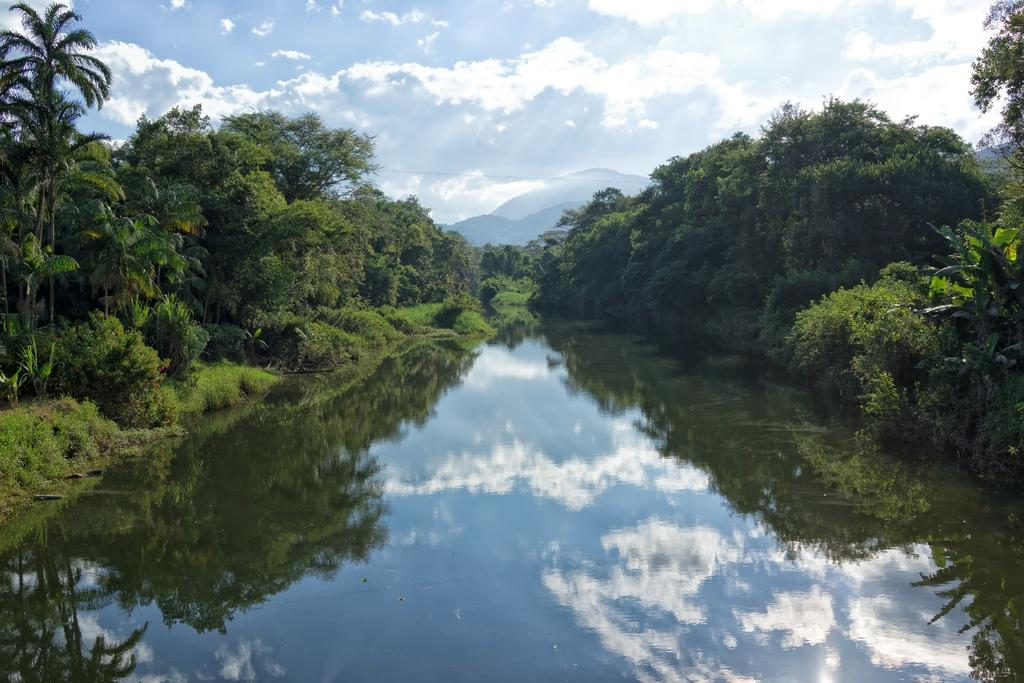What type of vegetation can be seen in the image? There are trees in the image. What is the color of the trees? The trees are green in color. What else is visible in the image besides the trees? There is water visible in the image. What can be seen in the background of the image? The sky is visible in the background of the image. What colors are present in the sky? The sky has both white and blue colors. Can you see a rake being used to gather rice in the image? There is no rake or rice present in the image. 